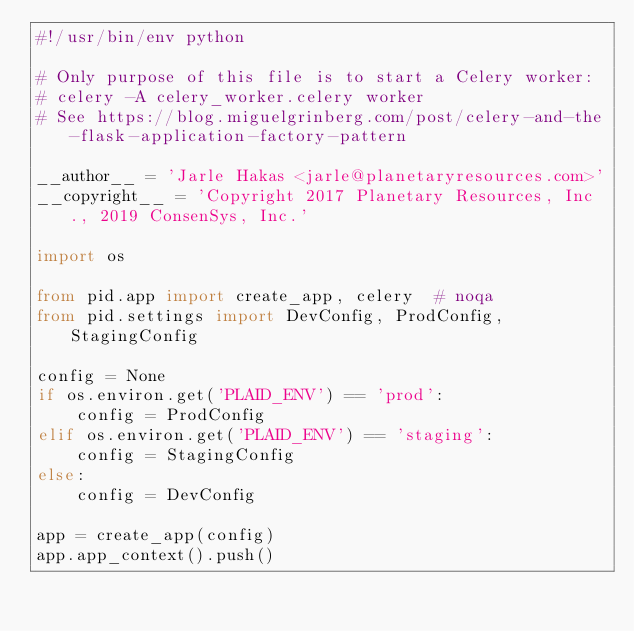Convert code to text. <code><loc_0><loc_0><loc_500><loc_500><_Python_>#!/usr/bin/env python

# Only purpose of this file is to start a Celery worker:
# celery -A celery_worker.celery worker
# See https://blog.miguelgrinberg.com/post/celery-and-the-flask-application-factory-pattern

__author__ = 'Jarle Hakas <jarle@planetaryresources.com>'
__copyright__ = 'Copyright 2017 Planetary Resources, Inc., 2019 ConsenSys, Inc.'

import os

from pid.app import create_app, celery  # noqa
from pid.settings import DevConfig, ProdConfig, StagingConfig

config = None
if os.environ.get('PLAID_ENV') == 'prod':
    config = ProdConfig
elif os.environ.get('PLAID_ENV') == 'staging':
    config = StagingConfig
else:
    config = DevConfig

app = create_app(config)
app.app_context().push()
</code> 